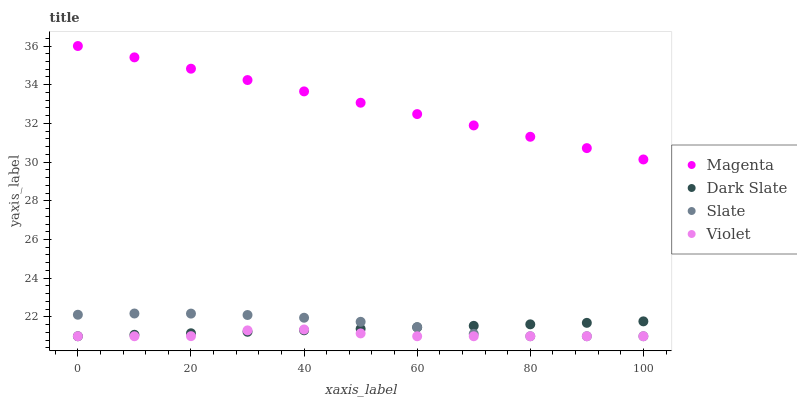Does Violet have the minimum area under the curve?
Answer yes or no. Yes. Does Magenta have the maximum area under the curve?
Answer yes or no. Yes. Does Slate have the minimum area under the curve?
Answer yes or no. No. Does Slate have the maximum area under the curve?
Answer yes or no. No. Is Dark Slate the smoothest?
Answer yes or no. Yes. Is Violet the roughest?
Answer yes or no. Yes. Is Magenta the smoothest?
Answer yes or no. No. Is Magenta the roughest?
Answer yes or no. No. Does Dark Slate have the lowest value?
Answer yes or no. Yes. Does Magenta have the lowest value?
Answer yes or no. No. Does Magenta have the highest value?
Answer yes or no. Yes. Does Slate have the highest value?
Answer yes or no. No. Is Dark Slate less than Magenta?
Answer yes or no. Yes. Is Magenta greater than Slate?
Answer yes or no. Yes. Does Violet intersect Dark Slate?
Answer yes or no. Yes. Is Violet less than Dark Slate?
Answer yes or no. No. Is Violet greater than Dark Slate?
Answer yes or no. No. Does Dark Slate intersect Magenta?
Answer yes or no. No. 